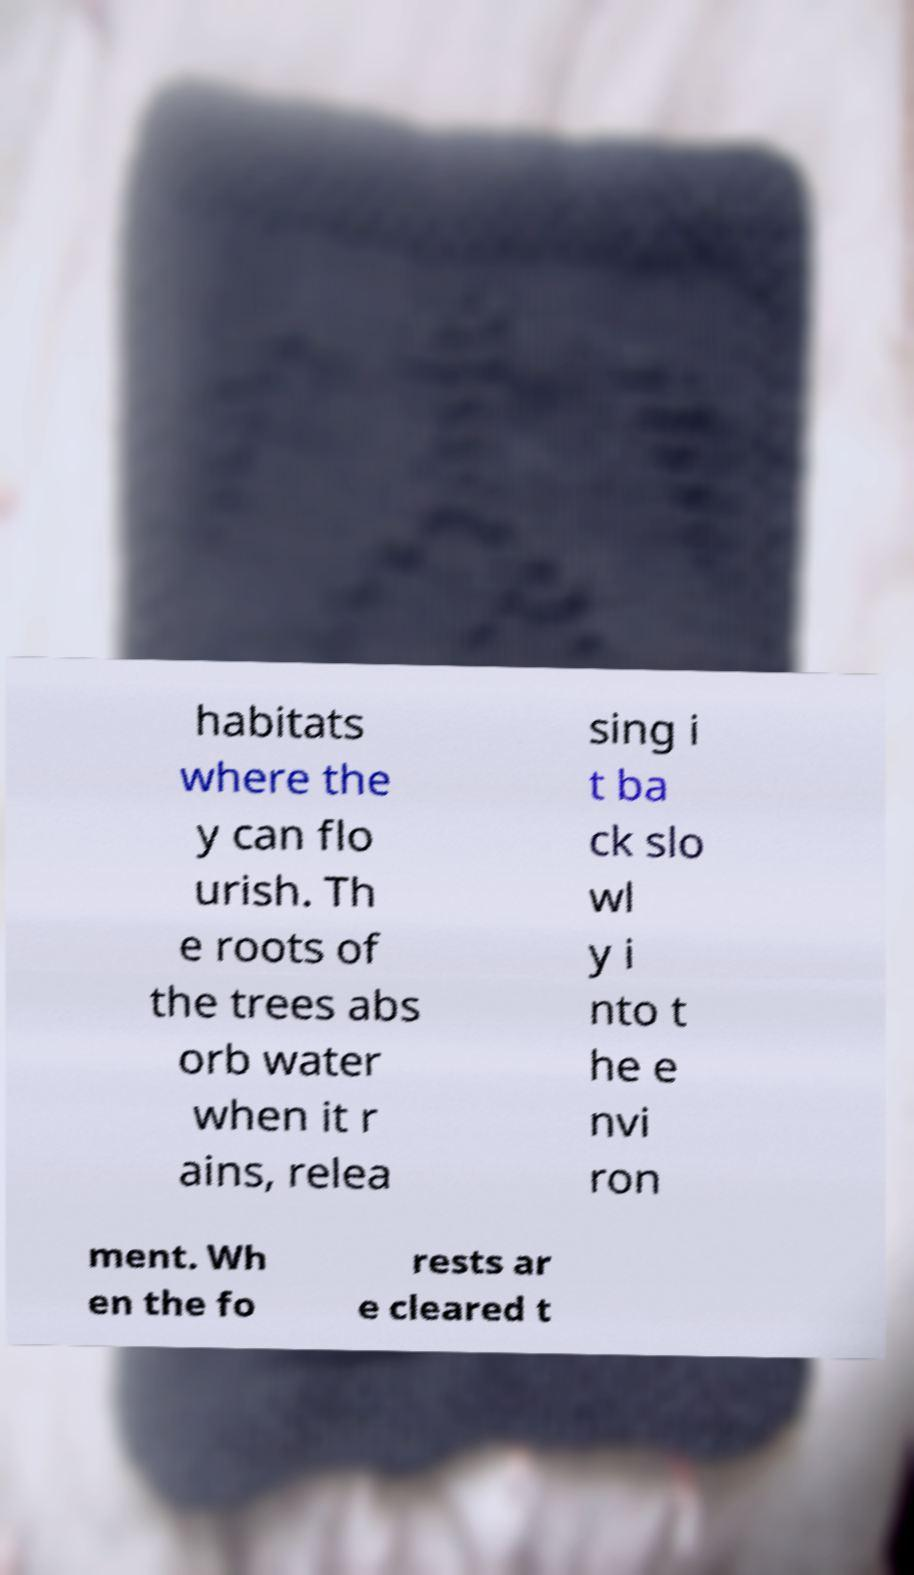Could you assist in decoding the text presented in this image and type it out clearly? habitats where the y can flo urish. Th e roots of the trees abs orb water when it r ains, relea sing i t ba ck slo wl y i nto t he e nvi ron ment. Wh en the fo rests ar e cleared t 